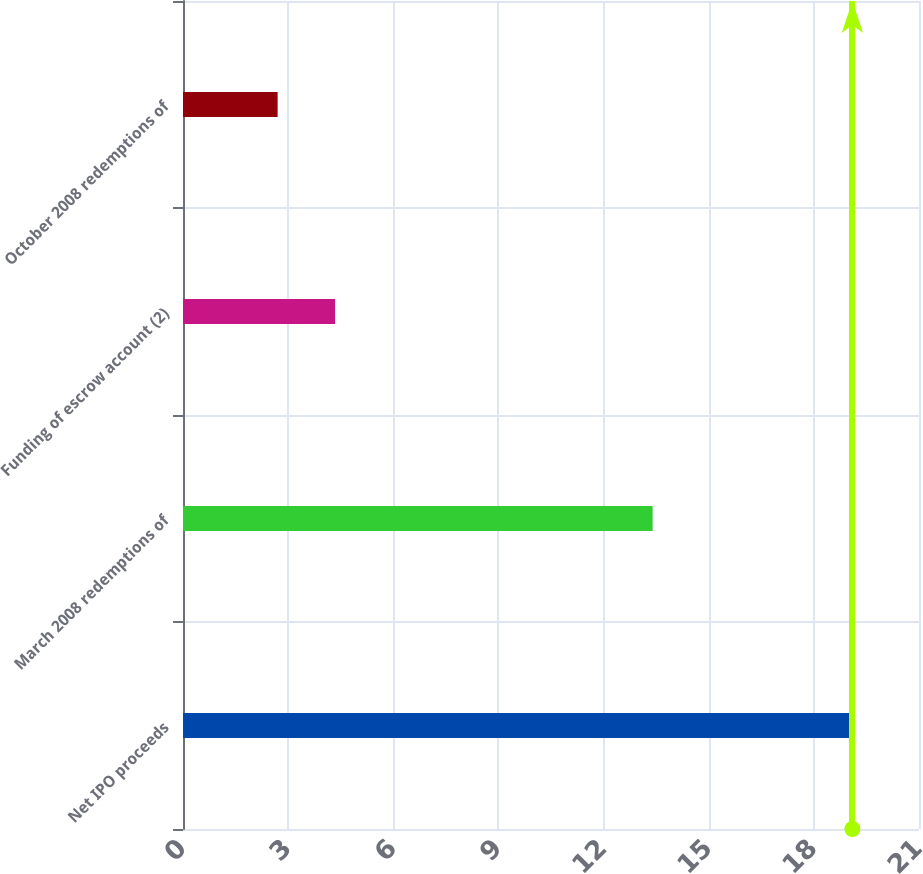Convert chart. <chart><loc_0><loc_0><loc_500><loc_500><bar_chart><fcel>Net IPO proceeds<fcel>March 2008 redemptions of<fcel>Funding of escrow account (2)<fcel>October 2008 redemptions of<nl><fcel>19.1<fcel>13.4<fcel>4.34<fcel>2.7<nl></chart> 